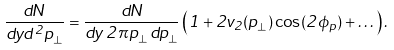Convert formula to latex. <formula><loc_0><loc_0><loc_500><loc_500>\frac { d N } { d y d ^ { 2 } p _ { \bot } } = \frac { d N } { d y \, 2 \pi p _ { \bot } \, d p _ { \bot } } \left ( 1 + 2 v _ { 2 } ( p _ { \bot } ) \cos ( 2 \phi _ { p } ) + \dots \right ) .</formula> 